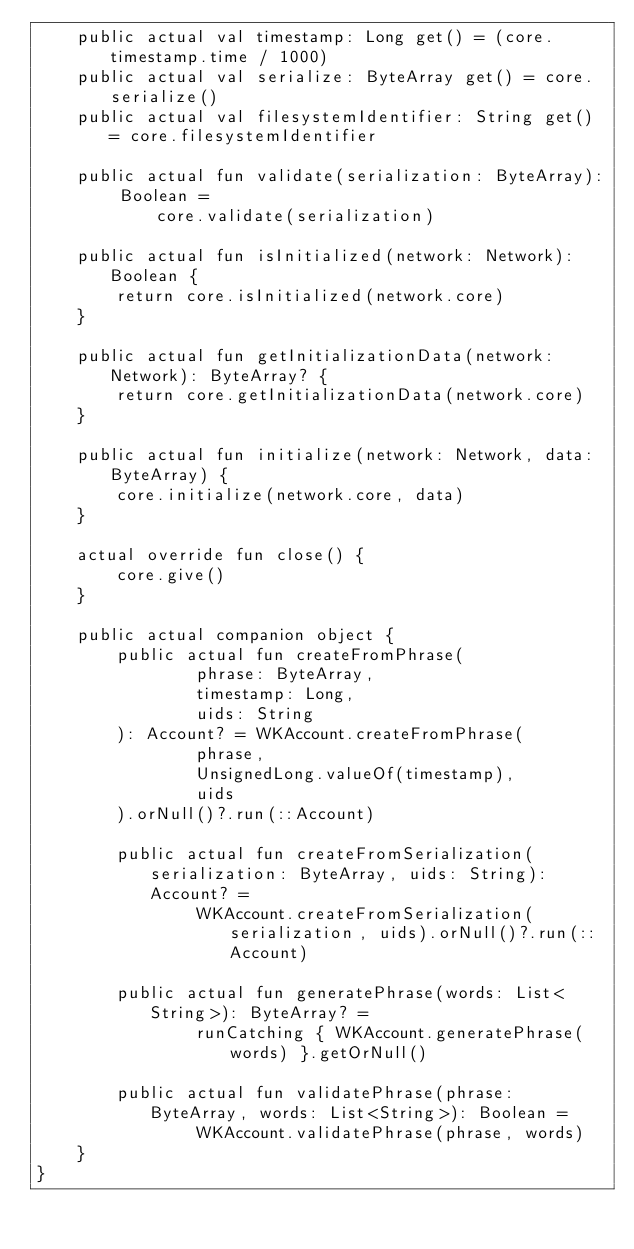<code> <loc_0><loc_0><loc_500><loc_500><_Kotlin_>    public actual val timestamp: Long get() = (core.timestamp.time / 1000)
    public actual val serialize: ByteArray get() = core.serialize()
    public actual val filesystemIdentifier: String get() = core.filesystemIdentifier

    public actual fun validate(serialization: ByteArray): Boolean =
            core.validate(serialization)

    public actual fun isInitialized(network: Network): Boolean {
        return core.isInitialized(network.core)
    }

    public actual fun getInitializationData(network: Network): ByteArray? {
        return core.getInitializationData(network.core)
    }

    public actual fun initialize(network: Network, data: ByteArray) {
        core.initialize(network.core, data)
    }

    actual override fun close() {
        core.give()
    }

    public actual companion object {
        public actual fun createFromPhrase(
                phrase: ByteArray,
                timestamp: Long,
                uids: String
        ): Account? = WKAccount.createFromPhrase(
                phrase,
                UnsignedLong.valueOf(timestamp),
                uids
        ).orNull()?.run(::Account)

        public actual fun createFromSerialization(serialization: ByteArray, uids: String): Account? =
                WKAccount.createFromSerialization(serialization, uids).orNull()?.run(::Account)

        public actual fun generatePhrase(words: List<String>): ByteArray? =
                runCatching { WKAccount.generatePhrase(words) }.getOrNull()

        public actual fun validatePhrase(phrase: ByteArray, words: List<String>): Boolean =
                WKAccount.validatePhrase(phrase, words)
    }
}
</code> 